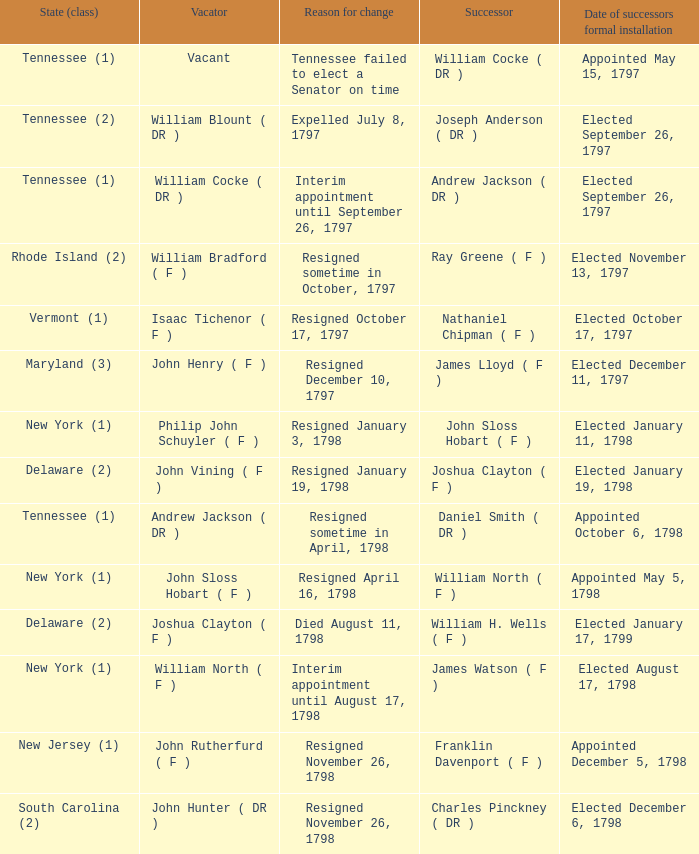Could you help me parse every detail presented in this table? {'header': ['State (class)', 'Vacator', 'Reason for change', 'Successor', 'Date of successors formal installation'], 'rows': [['Tennessee (1)', 'Vacant', 'Tennessee failed to elect a Senator on time', 'William Cocke ( DR )', 'Appointed May 15, 1797'], ['Tennessee (2)', 'William Blount ( DR )', 'Expelled July 8, 1797', 'Joseph Anderson ( DR )', 'Elected September 26, 1797'], ['Tennessee (1)', 'William Cocke ( DR )', 'Interim appointment until September 26, 1797', 'Andrew Jackson ( DR )', 'Elected September 26, 1797'], ['Rhode Island (2)', 'William Bradford ( F )', 'Resigned sometime in October, 1797', 'Ray Greene ( F )', 'Elected November 13, 1797'], ['Vermont (1)', 'Isaac Tichenor ( F )', 'Resigned October 17, 1797', 'Nathaniel Chipman ( F )', 'Elected October 17, 1797'], ['Maryland (3)', 'John Henry ( F )', 'Resigned December 10, 1797', 'James Lloyd ( F )', 'Elected December 11, 1797'], ['New York (1)', 'Philip John Schuyler ( F )', 'Resigned January 3, 1798', 'John Sloss Hobart ( F )', 'Elected January 11, 1798'], ['Delaware (2)', 'John Vining ( F )', 'Resigned January 19, 1798', 'Joshua Clayton ( F )', 'Elected January 19, 1798'], ['Tennessee (1)', 'Andrew Jackson ( DR )', 'Resigned sometime in April, 1798', 'Daniel Smith ( DR )', 'Appointed October 6, 1798'], ['New York (1)', 'John Sloss Hobart ( F )', 'Resigned April 16, 1798', 'William North ( F )', 'Appointed May 5, 1798'], ['Delaware (2)', 'Joshua Clayton ( F )', 'Died August 11, 1798', 'William H. Wells ( F )', 'Elected January 17, 1799'], ['New York (1)', 'William North ( F )', 'Interim appointment until August 17, 1798', 'James Watson ( F )', 'Elected August 17, 1798'], ['New Jersey (1)', 'John Rutherfurd ( F )', 'Resigned November 26, 1798', 'Franklin Davenport ( F )', 'Appointed December 5, 1798'], ['South Carolina (2)', 'John Hunter ( DR )', 'Resigned November 26, 1798', 'Charles Pinckney ( DR )', 'Elected December 6, 1798']]} What are all the states (class) when the reason for change was resigned November 26, 1798 and the vacator was John Hunter ( DR )? South Carolina (2). 